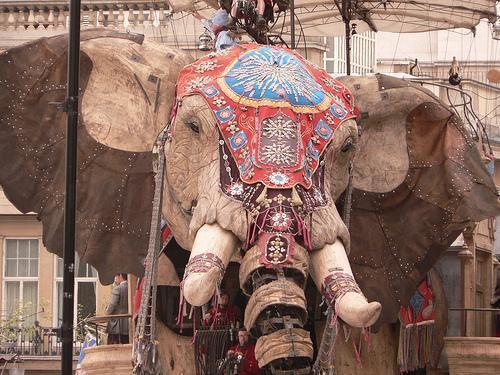How many elephants are there?
Give a very brief answer. 1. 